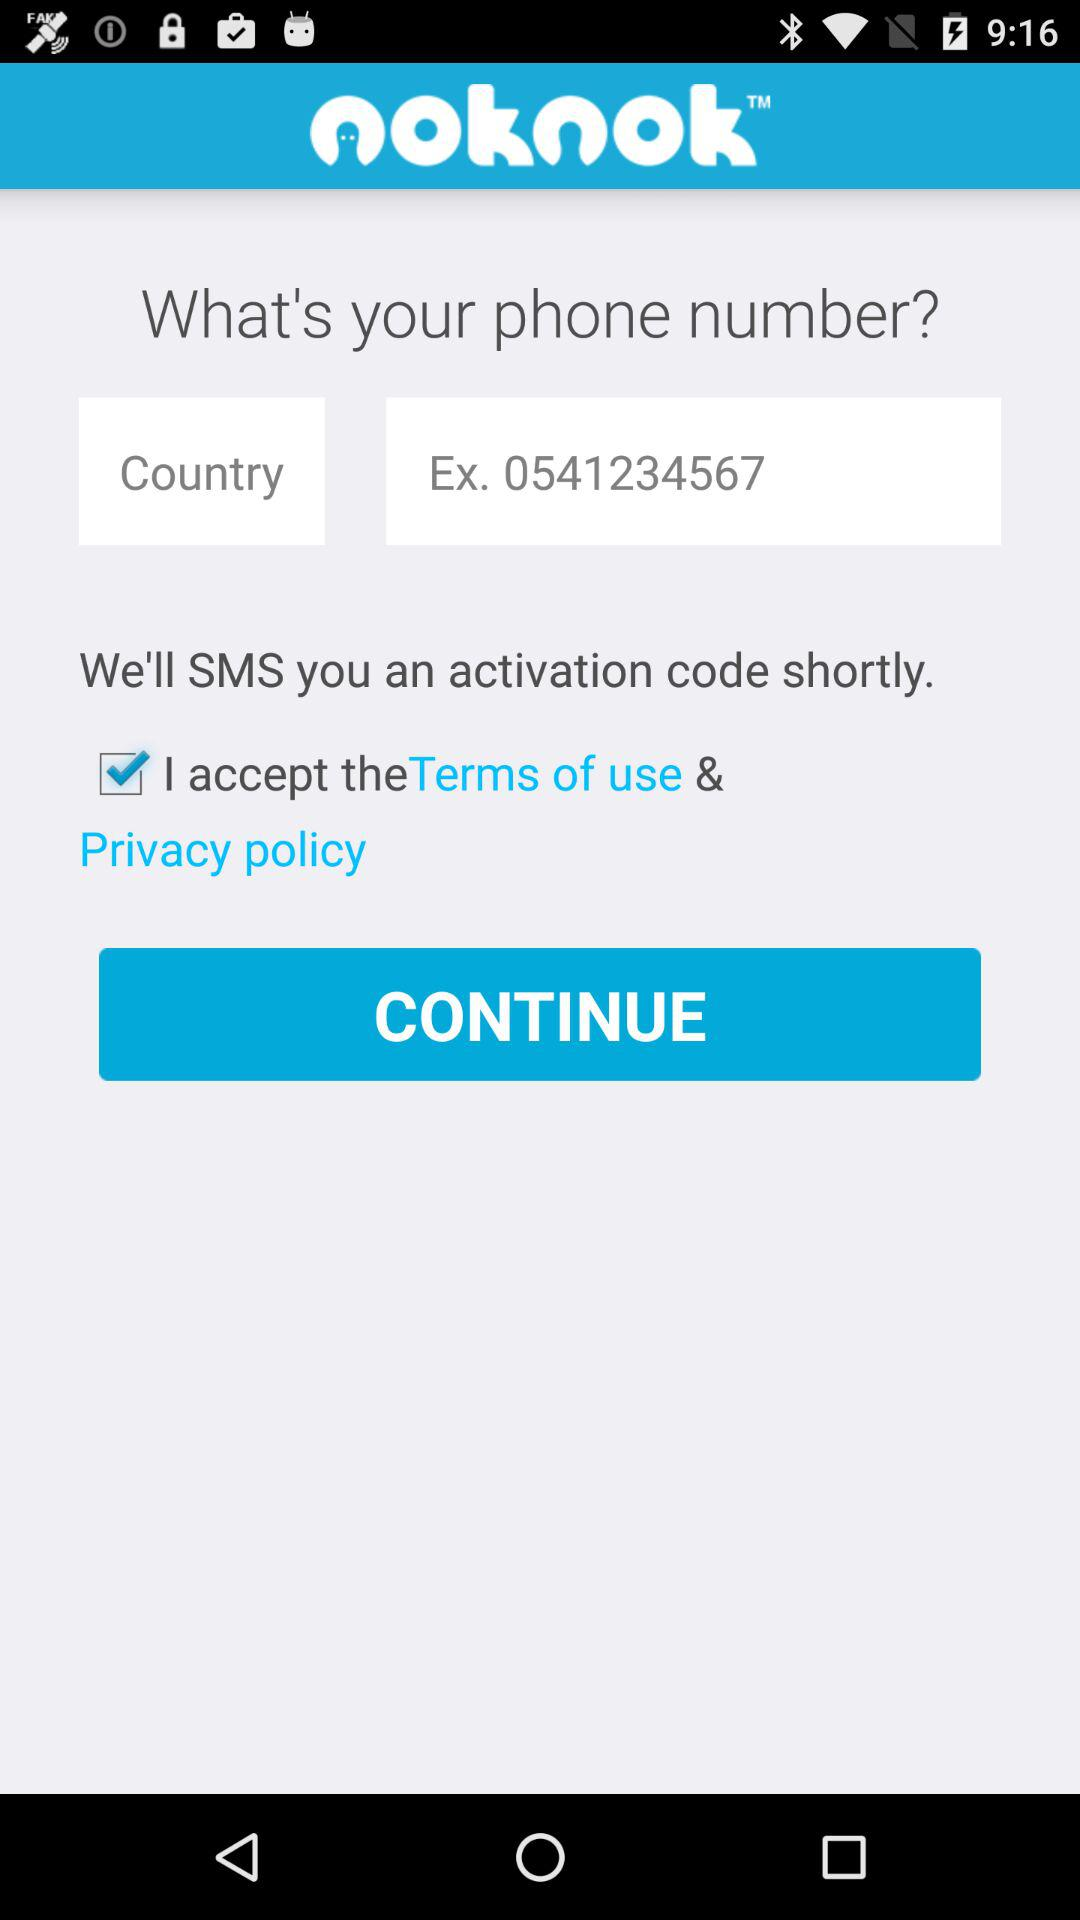What is the phone number? The phone number is 0541234567. 